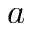Convert formula to latex. <formula><loc_0><loc_0><loc_500><loc_500>a</formula> 